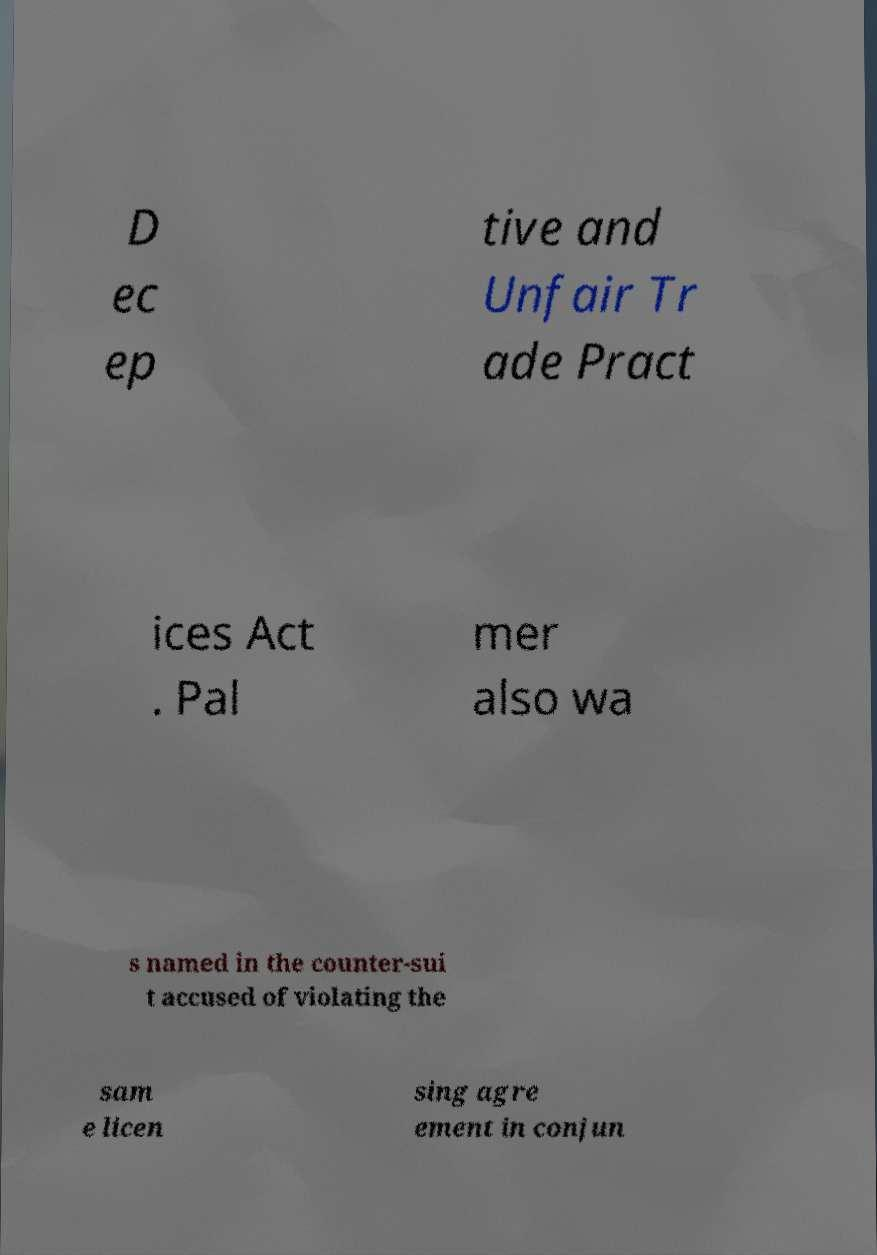I need the written content from this picture converted into text. Can you do that? D ec ep tive and Unfair Tr ade Pract ices Act . Pal mer also wa s named in the counter-sui t accused of violating the sam e licen sing agre ement in conjun 